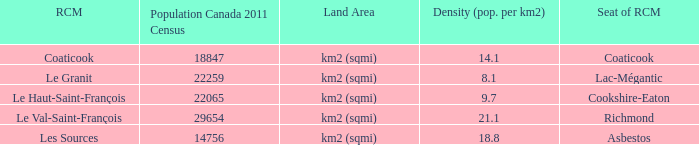What is the seat of the county that has a density of 14.1? Coaticook. 